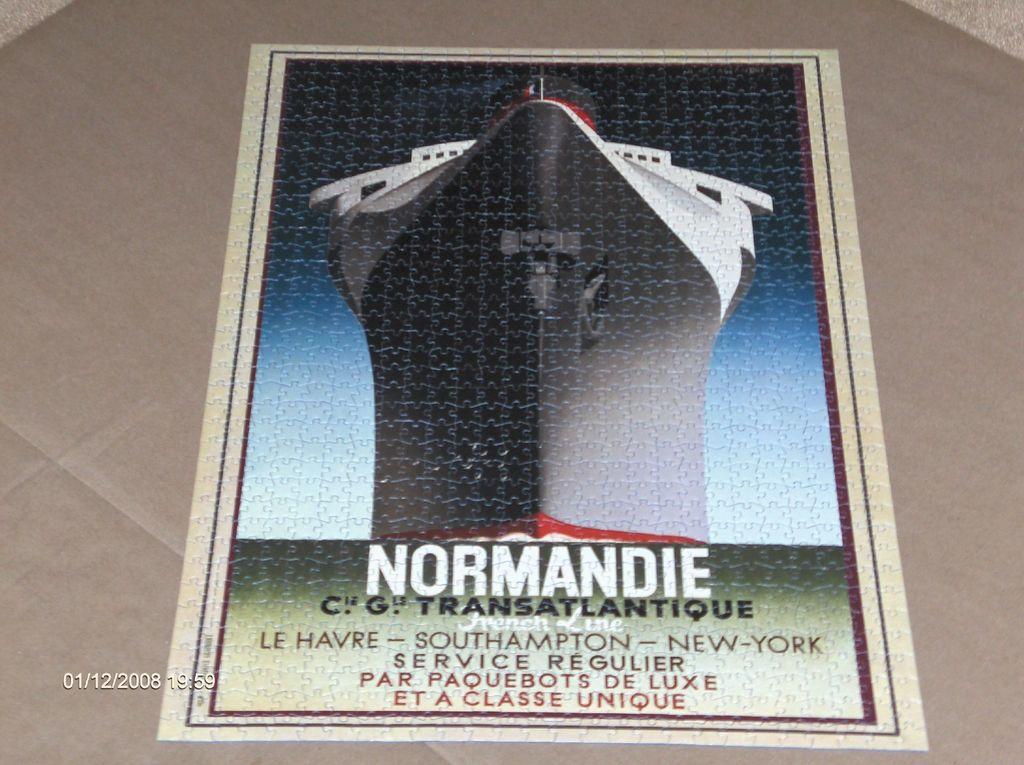What location is the boat from or going to?
Ensure brevity in your answer.  Normandie. What does it say on the bottom row of text?
Your answer should be very brief. Et a classe unique. 